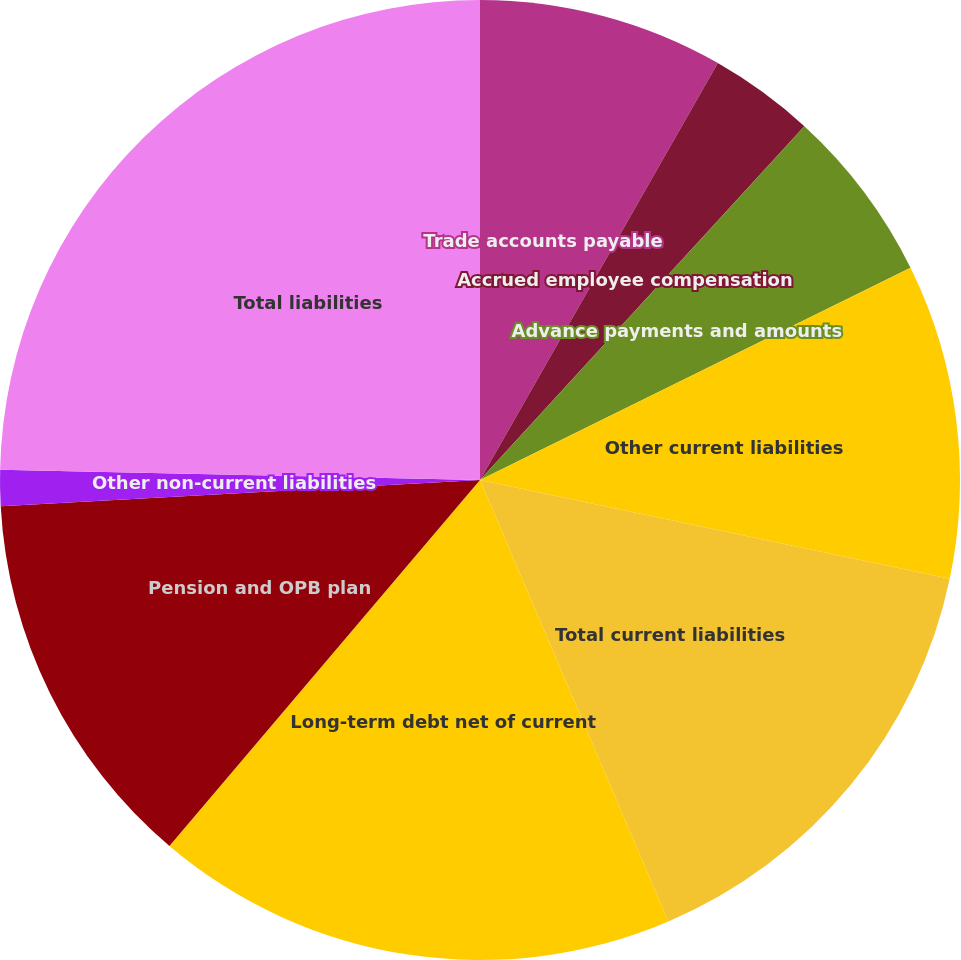<chart> <loc_0><loc_0><loc_500><loc_500><pie_chart><fcel>Trade accounts payable<fcel>Accrued employee compensation<fcel>Advance payments and amounts<fcel>Other current liabilities<fcel>Total current liabilities<fcel>Long-term debt net of current<fcel>Pension and OPB plan<fcel>Other non-current liabilities<fcel>Total liabilities<nl><fcel>8.25%<fcel>3.56%<fcel>5.9%<fcel>10.59%<fcel>15.28%<fcel>17.62%<fcel>12.93%<fcel>1.21%<fcel>24.66%<nl></chart> 